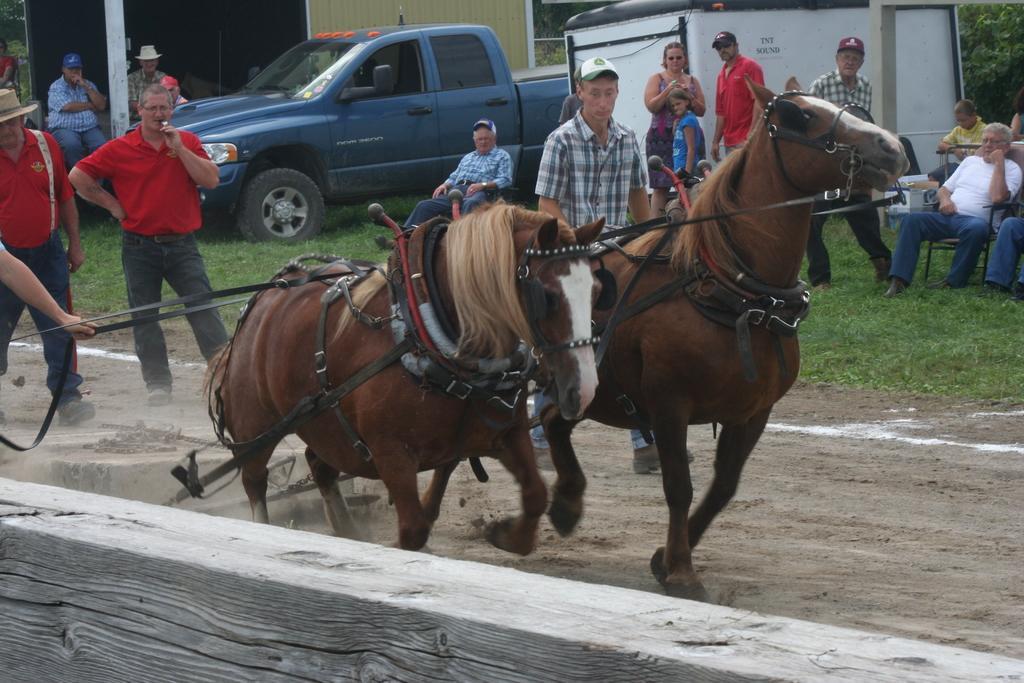Could you give a brief overview of what you see in this image? In the center of the image there are horses. There are people standing. At the bottom of the image there is a wooden wall. To the right side of the image there is sand. In the background of the image there are people sitting in chairs. There is a building. There is a car. There is a pole. 